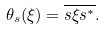<formula> <loc_0><loc_0><loc_500><loc_500>\theta _ { s } ( \xi ) = \overline { s \xi s ^ { * } } .</formula> 